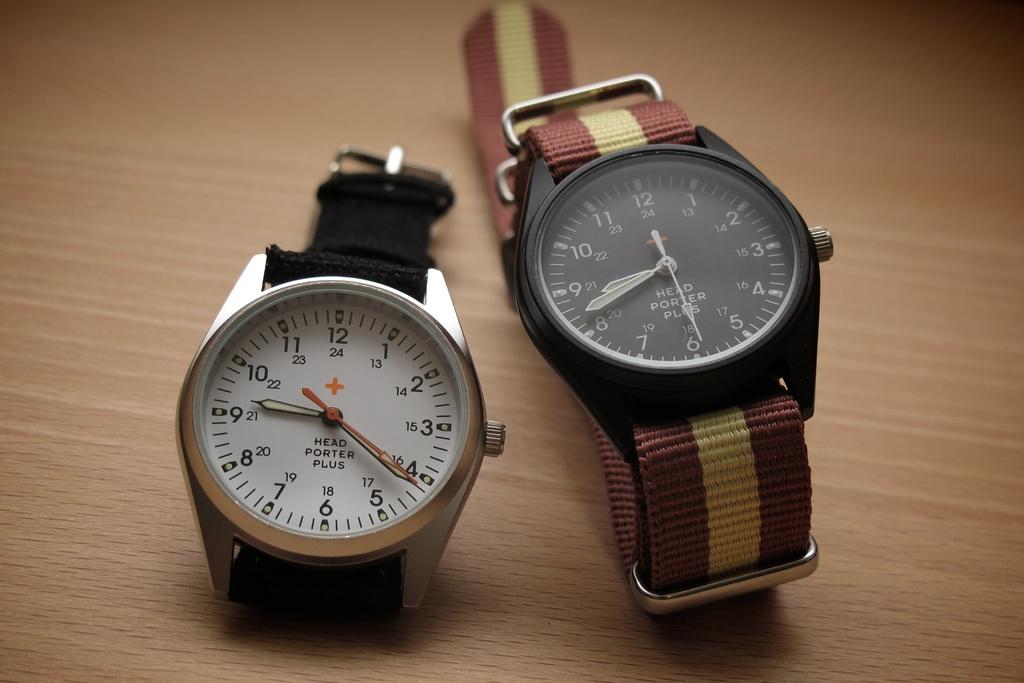What brand of watch is this?
Offer a terse response. Head porter plus. What time does the black face watch say?
Offer a very short reply. 8:42. 